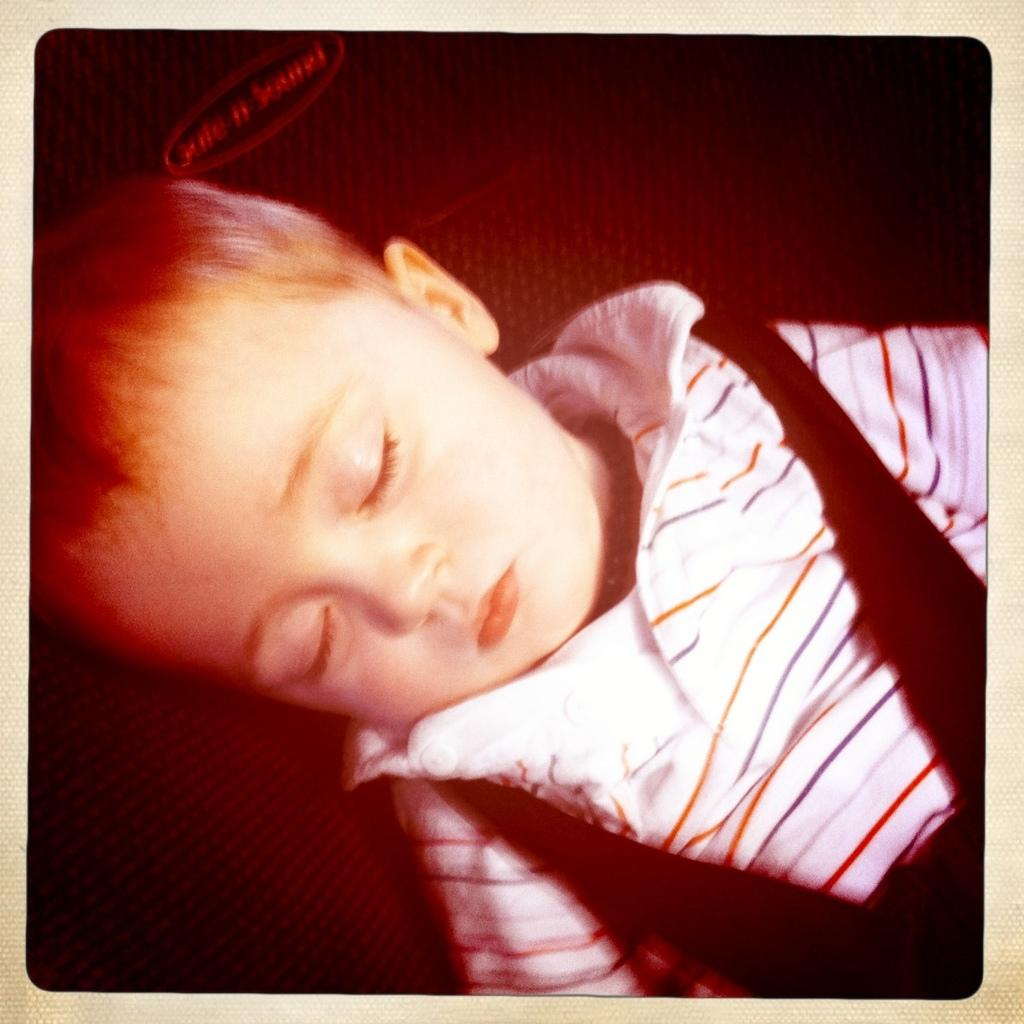What is the main subject of the image? The main subject of the image is a kid. What is the kid wearing in the image? The kid is wearing a white and black color dress. What is the kid doing in the image? The kid is sleeping. What type of texture can be seen on the tramp in the image? There is no tramp present in the image, so it is not possible to determine the texture of a tramp. 